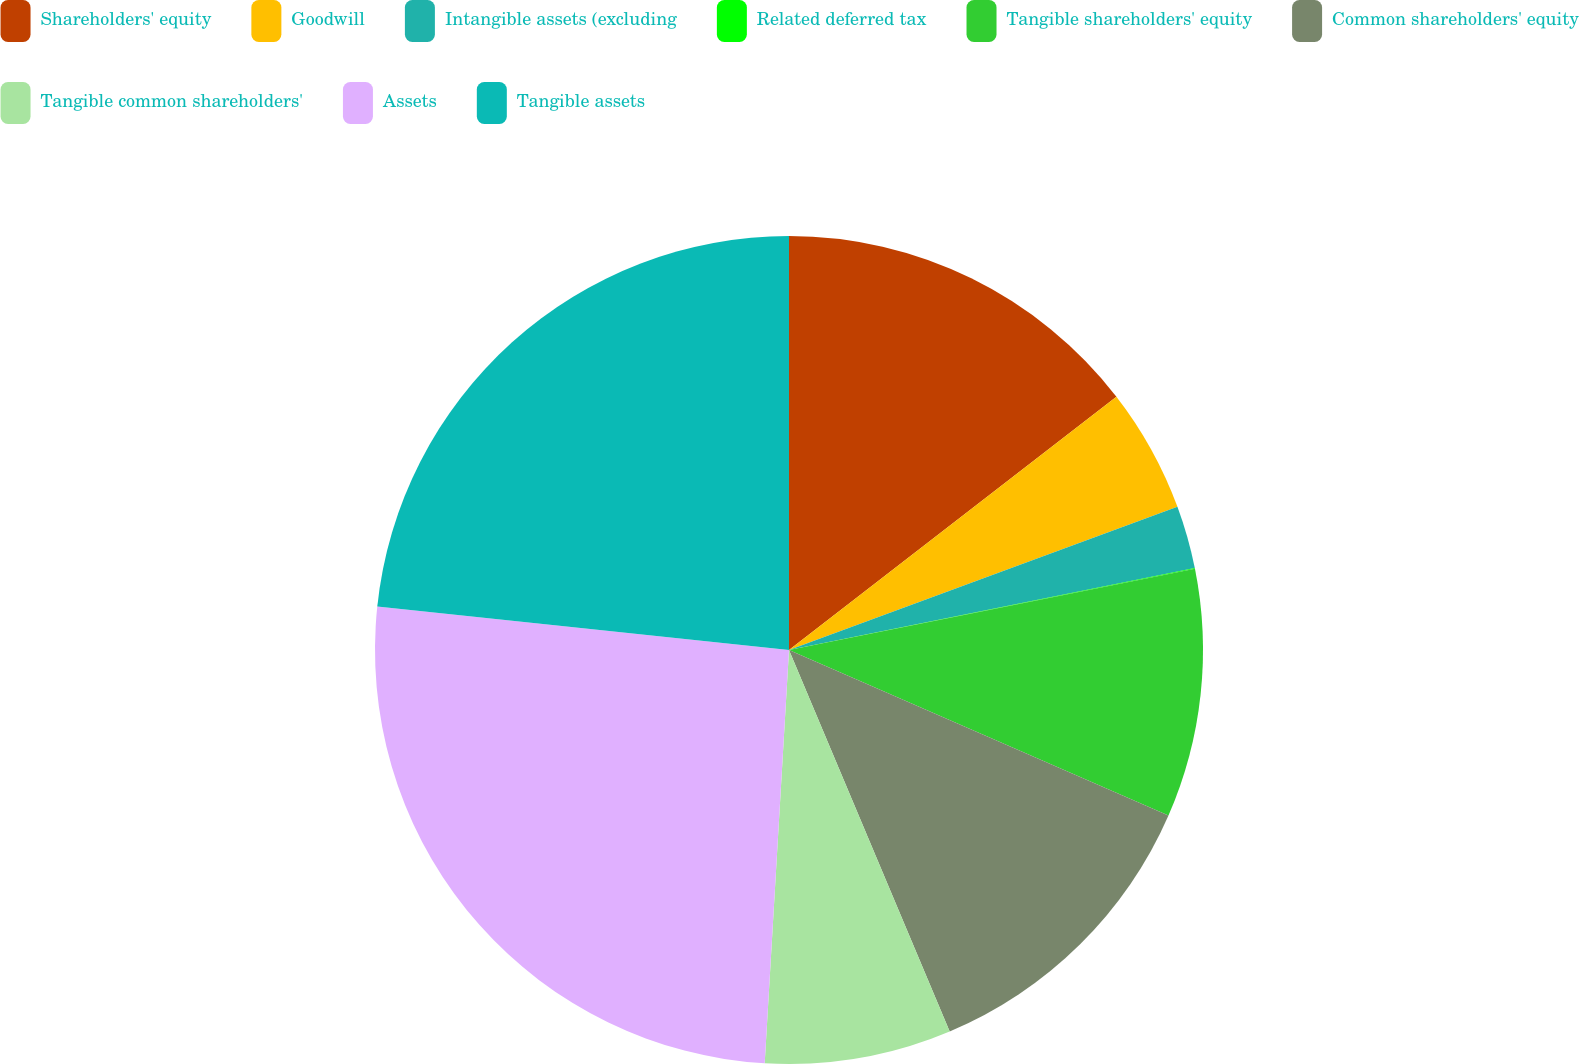Convert chart to OTSL. <chart><loc_0><loc_0><loc_500><loc_500><pie_chart><fcel>Shareholders' equity<fcel>Goodwill<fcel>Intangible assets (excluding<fcel>Related deferred tax<fcel>Tangible shareholders' equity<fcel>Common shareholders' equity<fcel>Tangible common shareholders'<fcel>Assets<fcel>Tangible assets<nl><fcel>14.52%<fcel>4.86%<fcel>2.45%<fcel>0.03%<fcel>9.69%<fcel>12.11%<fcel>7.28%<fcel>25.74%<fcel>23.33%<nl></chart> 